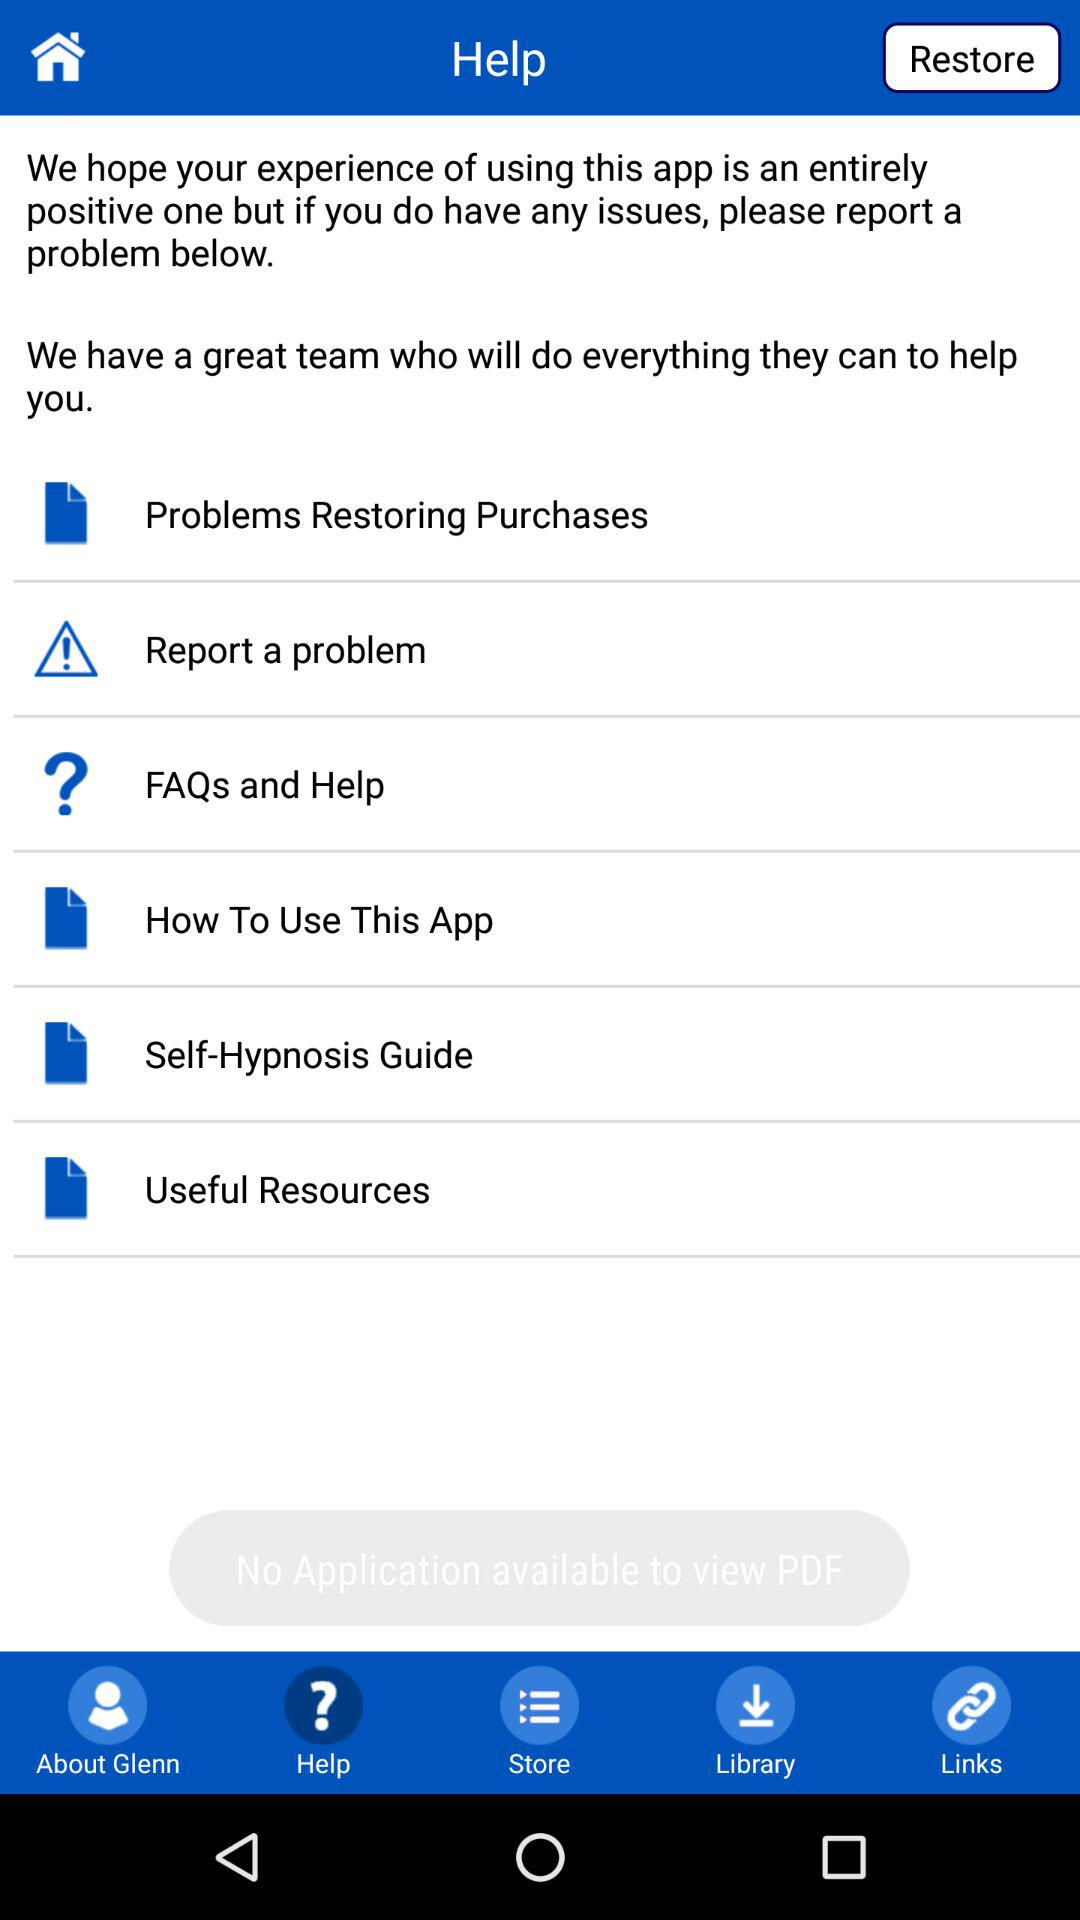How many items are in the Help menu?
Answer the question using a single word or phrase. 6 